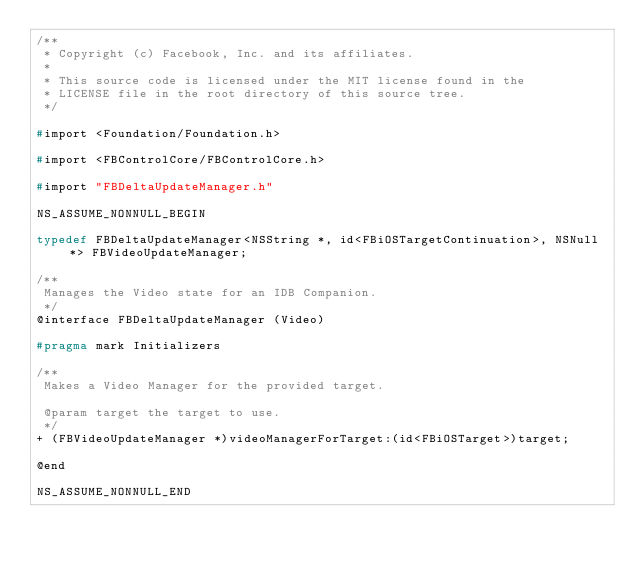Convert code to text. <code><loc_0><loc_0><loc_500><loc_500><_C_>/**
 * Copyright (c) Facebook, Inc. and its affiliates.
 *
 * This source code is licensed under the MIT license found in the
 * LICENSE file in the root directory of this source tree.
 */

#import <Foundation/Foundation.h>

#import <FBControlCore/FBControlCore.h>

#import "FBDeltaUpdateManager.h"

NS_ASSUME_NONNULL_BEGIN

typedef FBDeltaUpdateManager<NSString *, id<FBiOSTargetContinuation>, NSNull *> FBVideoUpdateManager;

/**
 Manages the Video state for an IDB Companion.
 */
@interface FBDeltaUpdateManager (Video)

#pragma mark Initializers

/**
 Makes a Video Manager for the provided target.

 @param target the target to use.
 */
+ (FBVideoUpdateManager *)videoManagerForTarget:(id<FBiOSTarget>)target;

@end

NS_ASSUME_NONNULL_END
</code> 